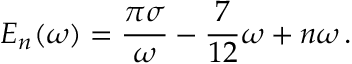Convert formula to latex. <formula><loc_0><loc_0><loc_500><loc_500>E _ { n } ( \omega ) = \frac { \pi \sigma } { \omega } - \frac { 7 } { 1 2 } \omega + n \omega \, .</formula> 